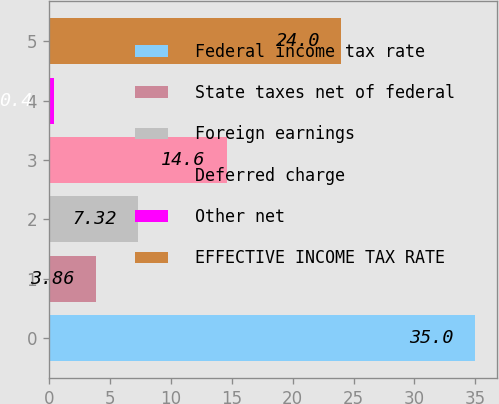Convert chart. <chart><loc_0><loc_0><loc_500><loc_500><bar_chart><fcel>Federal income tax rate<fcel>State taxes net of federal<fcel>Foreign earnings<fcel>Deferred charge<fcel>Other net<fcel>EFFECTIVE INCOME TAX RATE<nl><fcel>35<fcel>3.86<fcel>7.32<fcel>14.6<fcel>0.4<fcel>24<nl></chart> 